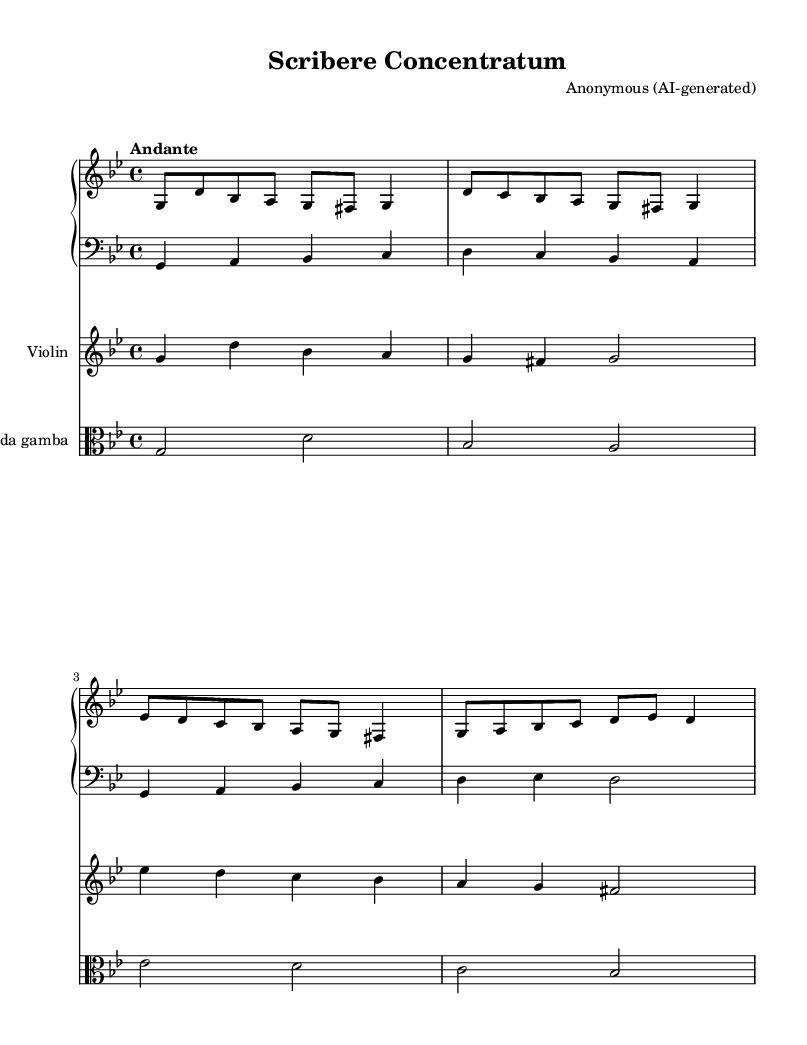What is the time signature of this music? The time signature is indicated at the beginning of the score, shown as "4/4". This means there are four beats per measure, and a quarter note receives one beat.
Answer: 4/4 What is the key signature of this music? The key signature, found at the beginning of the staff, indicates that the piece is in G minor. This is determined by looking for the flats present; in G minor, there are two flats: B and E.
Answer: G minor What is the tempo marking for this piece? The tempo marking at the beginning of the score states "Andante", which indicates a moderate walking pace for the performance of the music.
Answer: Andante How many instruments are featured in this score? The score has four distinct parts for different instruments: a harpsichord, a violin, a viola da gamba, and a bass. Each instrument is indicated on its own staff within the score.
Answer: Four What is the highest note in the violin part? By examining the violin staff, the highest note played is D' (D in the octave above middle C), which occurs multiple times in the part.
Answer: D' Which instrument plays the bass line? The bass line is indicated on the lower staff of the score, labeled with the clef 'bass', which is typically played by a cello or similar string instruments.
Answer: Bass What is the texture of this chamber music? The texture can be described as polyphonic, as multiple independent melodies are woven together, typical of Baroque chamber music, with each instrument contributing its own melodic line.
Answer: Polyphonic 